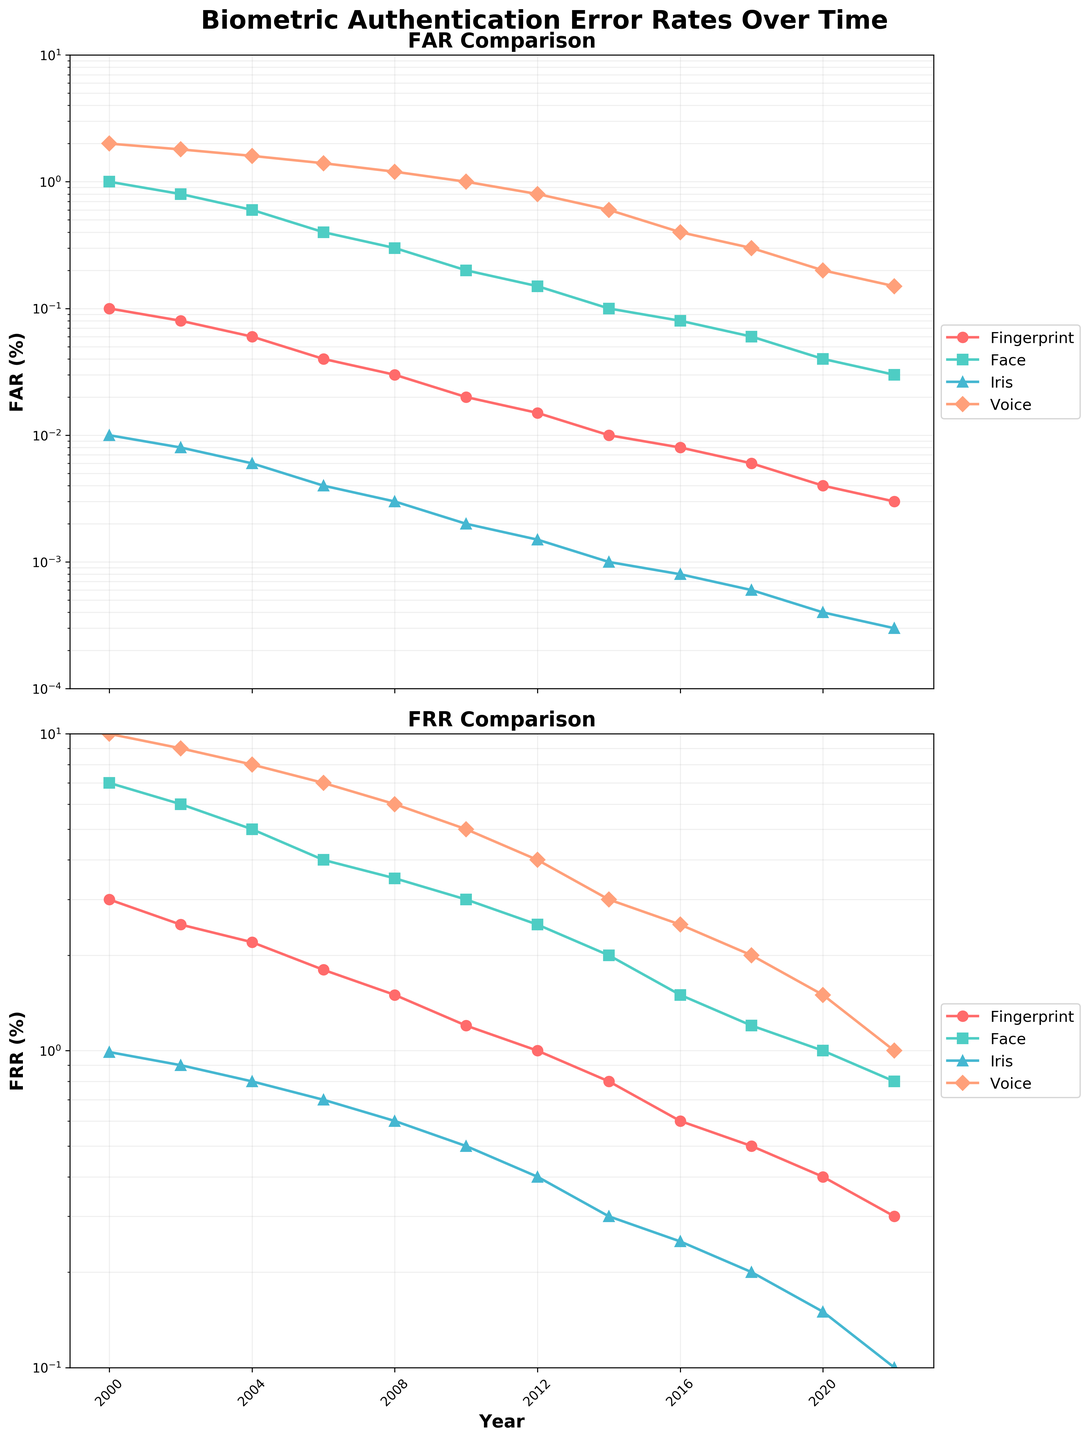What is the False Accept Rate (FAR) for Fingerprint in 2020? The FAR for Fingerprint in 2020 is represented by a point on the Fingerprint line in the FAR pane. Following the Fingerprint line to the year 2020, the value is 0.004.
Answer: 0.004 Which biometric technology showed the most significant reduction in False Reject Rate (FRR) from 2000 to 2022? To determine the most significant reduction in FRR, look at the FRR values in 2000 and 2022 for each biometric technology. Calculate the difference for each: Fingerprint (3.0 to 0.3), Face (7.0 to 0.8), Iris (0.99 to 0.1), and Voice (10.0 to 1.0). The largest reduction is for Face, with a reduction of 6.2.
Answer: Face Which biometric method had the lowest False Accept Rate (FAR) in 2004? Check the false accept rates for the year 2004 across all biometric technologies. The values are as follows: Fingerprint (0.06), Face (0.6), Iris (0.006), and Voice (1.6). The lowest value is for Iris at 0.006.
Answer: Iris By how much did the False Reject Rate (FRR) decrease for Voice recognition from 2008 to 2014? Subtract the FRR for Voice in 2014 (3.0) from the FRR in 2008 (6.0). The calculation is 6.0 - 3.0 = 3.0.
Answer: 3.0 Which technology had a higher False Reject Rate (FRR) in 2016, Iris or Voice? Compare the FRR values in 2016. For Iris, the FRR is 0.25, and for Voice, the FRR is 2.5. Voice has the higher FRR.
Answer: Voice What trend is observed for the False Accept Rate (FAR) of Iris recognition from 2000 to 2022? Observe the Iris FAR line from 2000 to 2022. The trend shows a consistent decrease from 0.01 in 2000 to 0.0003 in 2022.
Answer: Decreasing What can you deduce about the general trend in error rates (both FAR and FRR) across all technologies over the period from 2000 to 2022? Observe the general trends of all the lines in both the FAR and FRR panes from 2000 to 2022. All biometric technologies show a downward trend in both FAR and FRR over time, indicating improvements in accuracy.
Answer: Improving In 2012, which technology has the highest False Accept Rate (FAR) and which has the lowest? Check the FAR values in 2012 for all technologies. The highest FAR is for Voice (0.8) and the lowest is for Iris (0.0015).
Answer: Highest: Voice, Lowest: Iris 